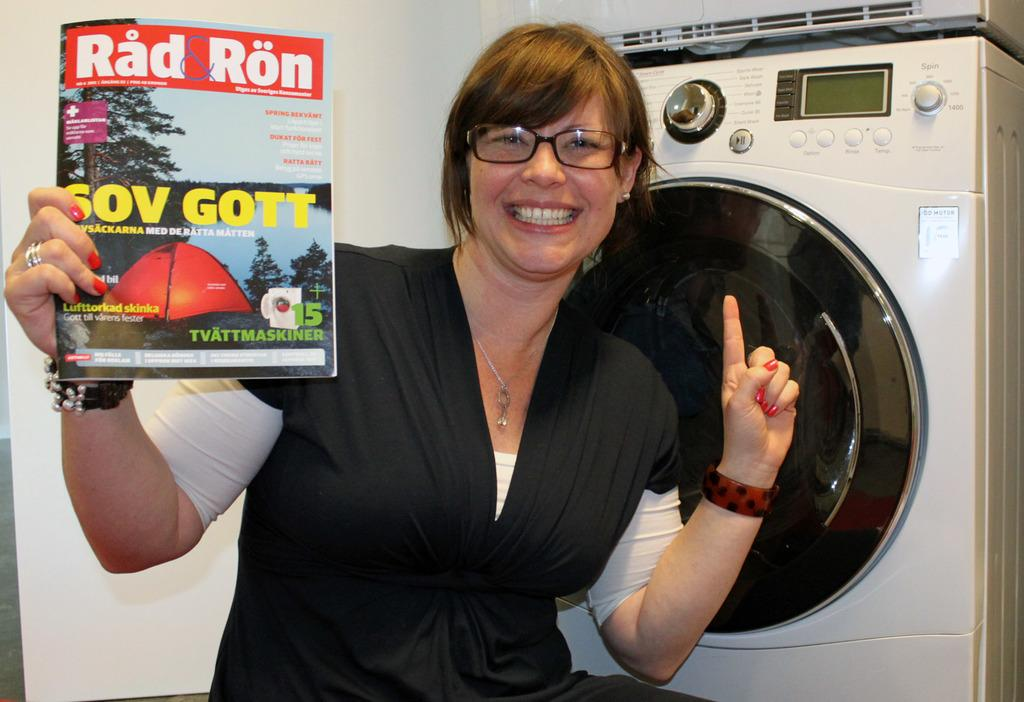Provide a one-sentence caption for the provided image. A Rad Ron magazine held up by a smiling lady. 